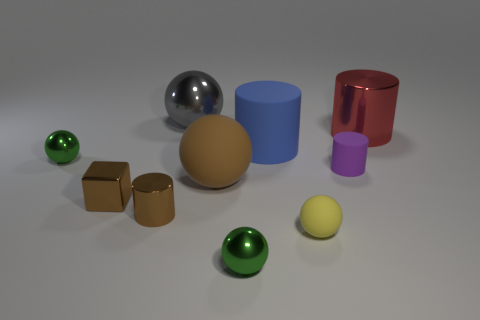The matte object that is the same color as the block is what shape?
Ensure brevity in your answer.  Sphere. Are there more large shiny objects that are in front of the gray object than big yellow blocks?
Offer a very short reply. Yes. What is the size of the shiny thing that is both in front of the large blue thing and behind the small brown cube?
Your answer should be very brief. Small. There is a blue thing that is the same shape as the purple rubber thing; what is it made of?
Provide a succinct answer. Rubber. There is a ball behind the red metallic thing; is it the same size as the large rubber cylinder?
Keep it short and to the point. Yes. There is a shiny object that is both behind the big rubber sphere and to the left of the gray shiny thing; what color is it?
Offer a terse response. Green. What number of brown cylinders are on the left side of the green ball that is on the right side of the large gray shiny object?
Give a very brief answer. 1. Is the shape of the yellow rubber object the same as the large gray thing?
Offer a very short reply. Yes. Are there any other things that are the same color as the tiny matte ball?
Make the answer very short. No. Do the large brown thing and the small yellow object in front of the large blue cylinder have the same shape?
Offer a very short reply. Yes. 